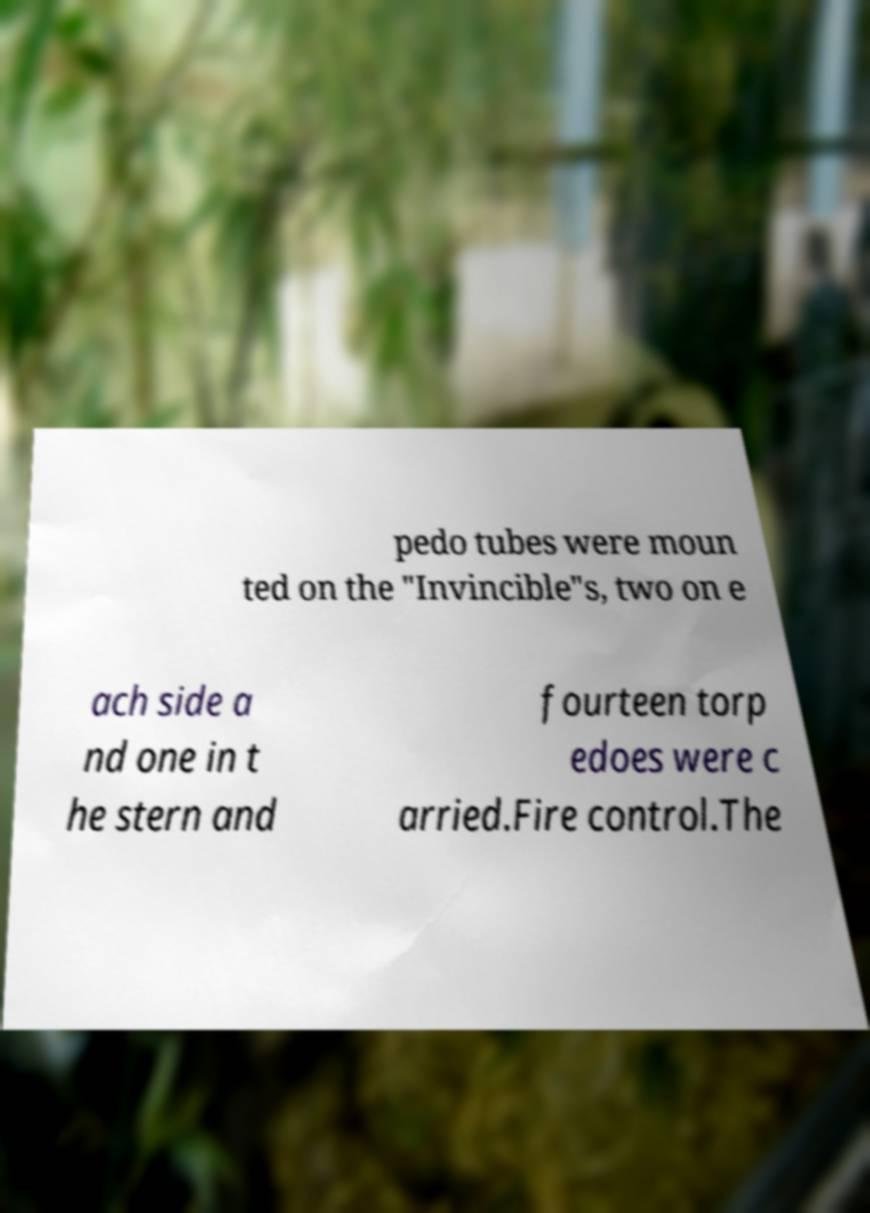I need the written content from this picture converted into text. Can you do that? pedo tubes were moun ted on the "Invincible"s, two on e ach side a nd one in t he stern and fourteen torp edoes were c arried.Fire control.The 